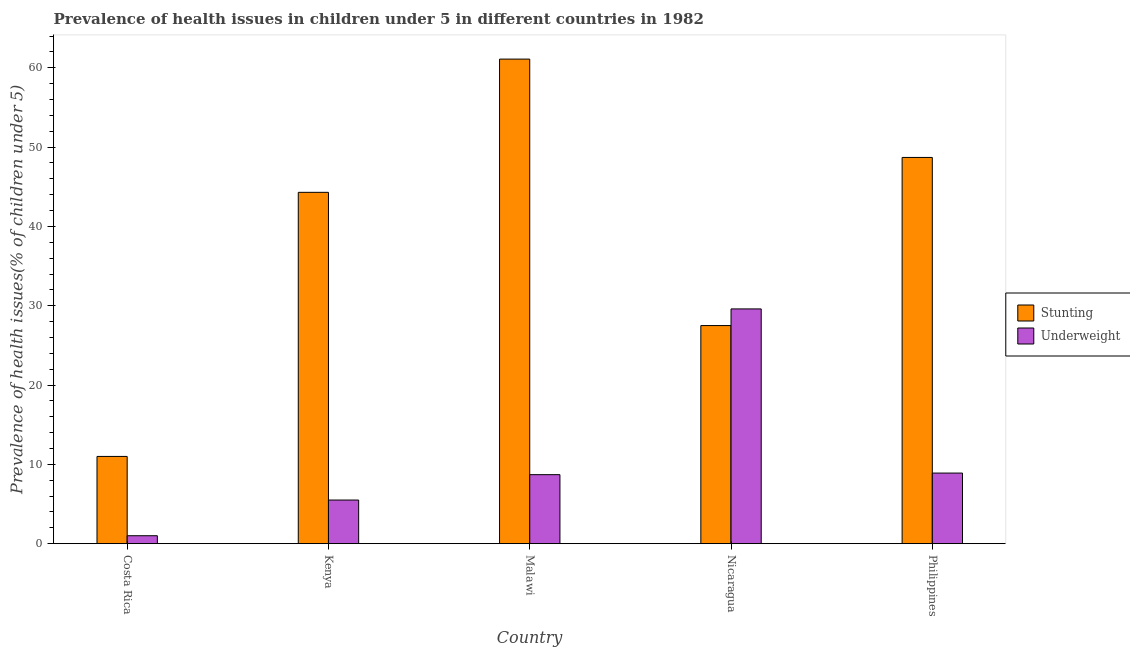Are the number of bars on each tick of the X-axis equal?
Provide a short and direct response. Yes. How many bars are there on the 2nd tick from the left?
Give a very brief answer. 2. What is the label of the 4th group of bars from the left?
Give a very brief answer. Nicaragua. In how many cases, is the number of bars for a given country not equal to the number of legend labels?
Offer a very short reply. 0. What is the percentage of stunted children in Philippines?
Offer a terse response. 48.7. Across all countries, what is the maximum percentage of underweight children?
Your response must be concise. 29.6. In which country was the percentage of stunted children maximum?
Ensure brevity in your answer.  Malawi. In which country was the percentage of underweight children minimum?
Keep it short and to the point. Costa Rica. What is the total percentage of stunted children in the graph?
Keep it short and to the point. 192.6. What is the difference between the percentage of stunted children in Costa Rica and that in Philippines?
Offer a very short reply. -37.7. What is the difference between the percentage of stunted children in Costa Rica and the percentage of underweight children in Nicaragua?
Your answer should be compact. -18.6. What is the average percentage of stunted children per country?
Your answer should be compact. 38.52. What is the difference between the percentage of underweight children and percentage of stunted children in Costa Rica?
Offer a terse response. -10. What is the ratio of the percentage of underweight children in Malawi to that in Philippines?
Provide a short and direct response. 0.98. Is the difference between the percentage of stunted children in Kenya and Philippines greater than the difference between the percentage of underweight children in Kenya and Philippines?
Provide a succinct answer. No. What is the difference between the highest and the second highest percentage of stunted children?
Your answer should be compact. 12.4. What is the difference between the highest and the lowest percentage of stunted children?
Keep it short and to the point. 50.1. In how many countries, is the percentage of stunted children greater than the average percentage of stunted children taken over all countries?
Offer a terse response. 3. What does the 2nd bar from the left in Philippines represents?
Make the answer very short. Underweight. What does the 1st bar from the right in Kenya represents?
Your answer should be very brief. Underweight. Are all the bars in the graph horizontal?
Ensure brevity in your answer.  No. Does the graph contain grids?
Give a very brief answer. No. What is the title of the graph?
Offer a very short reply. Prevalence of health issues in children under 5 in different countries in 1982. Does "Infant" appear as one of the legend labels in the graph?
Keep it short and to the point. No. What is the label or title of the X-axis?
Your response must be concise. Country. What is the label or title of the Y-axis?
Your answer should be very brief. Prevalence of health issues(% of children under 5). What is the Prevalence of health issues(% of children under 5) of Underweight in Costa Rica?
Provide a succinct answer. 1. What is the Prevalence of health issues(% of children under 5) of Stunting in Kenya?
Your answer should be compact. 44.3. What is the Prevalence of health issues(% of children under 5) in Stunting in Malawi?
Offer a very short reply. 61.1. What is the Prevalence of health issues(% of children under 5) in Underweight in Malawi?
Keep it short and to the point. 8.7. What is the Prevalence of health issues(% of children under 5) in Stunting in Nicaragua?
Make the answer very short. 27.5. What is the Prevalence of health issues(% of children under 5) in Underweight in Nicaragua?
Ensure brevity in your answer.  29.6. What is the Prevalence of health issues(% of children under 5) in Stunting in Philippines?
Make the answer very short. 48.7. What is the Prevalence of health issues(% of children under 5) of Underweight in Philippines?
Keep it short and to the point. 8.9. Across all countries, what is the maximum Prevalence of health issues(% of children under 5) of Stunting?
Give a very brief answer. 61.1. Across all countries, what is the maximum Prevalence of health issues(% of children under 5) in Underweight?
Provide a succinct answer. 29.6. Across all countries, what is the minimum Prevalence of health issues(% of children under 5) of Stunting?
Keep it short and to the point. 11. What is the total Prevalence of health issues(% of children under 5) of Stunting in the graph?
Ensure brevity in your answer.  192.6. What is the total Prevalence of health issues(% of children under 5) of Underweight in the graph?
Keep it short and to the point. 53.7. What is the difference between the Prevalence of health issues(% of children under 5) of Stunting in Costa Rica and that in Kenya?
Provide a short and direct response. -33.3. What is the difference between the Prevalence of health issues(% of children under 5) of Stunting in Costa Rica and that in Malawi?
Offer a terse response. -50.1. What is the difference between the Prevalence of health issues(% of children under 5) in Underweight in Costa Rica and that in Malawi?
Offer a very short reply. -7.7. What is the difference between the Prevalence of health issues(% of children under 5) of Stunting in Costa Rica and that in Nicaragua?
Ensure brevity in your answer.  -16.5. What is the difference between the Prevalence of health issues(% of children under 5) in Underweight in Costa Rica and that in Nicaragua?
Keep it short and to the point. -28.6. What is the difference between the Prevalence of health issues(% of children under 5) of Stunting in Costa Rica and that in Philippines?
Provide a succinct answer. -37.7. What is the difference between the Prevalence of health issues(% of children under 5) in Stunting in Kenya and that in Malawi?
Keep it short and to the point. -16.8. What is the difference between the Prevalence of health issues(% of children under 5) of Stunting in Kenya and that in Nicaragua?
Provide a short and direct response. 16.8. What is the difference between the Prevalence of health issues(% of children under 5) in Underweight in Kenya and that in Nicaragua?
Offer a very short reply. -24.1. What is the difference between the Prevalence of health issues(% of children under 5) of Stunting in Kenya and that in Philippines?
Your response must be concise. -4.4. What is the difference between the Prevalence of health issues(% of children under 5) in Stunting in Malawi and that in Nicaragua?
Keep it short and to the point. 33.6. What is the difference between the Prevalence of health issues(% of children under 5) of Underweight in Malawi and that in Nicaragua?
Your response must be concise. -20.9. What is the difference between the Prevalence of health issues(% of children under 5) in Underweight in Malawi and that in Philippines?
Keep it short and to the point. -0.2. What is the difference between the Prevalence of health issues(% of children under 5) of Stunting in Nicaragua and that in Philippines?
Keep it short and to the point. -21.2. What is the difference between the Prevalence of health issues(% of children under 5) of Underweight in Nicaragua and that in Philippines?
Provide a short and direct response. 20.7. What is the difference between the Prevalence of health issues(% of children under 5) in Stunting in Costa Rica and the Prevalence of health issues(% of children under 5) in Underweight in Kenya?
Provide a short and direct response. 5.5. What is the difference between the Prevalence of health issues(% of children under 5) in Stunting in Costa Rica and the Prevalence of health issues(% of children under 5) in Underweight in Nicaragua?
Your answer should be compact. -18.6. What is the difference between the Prevalence of health issues(% of children under 5) in Stunting in Costa Rica and the Prevalence of health issues(% of children under 5) in Underweight in Philippines?
Your answer should be compact. 2.1. What is the difference between the Prevalence of health issues(% of children under 5) in Stunting in Kenya and the Prevalence of health issues(% of children under 5) in Underweight in Malawi?
Provide a short and direct response. 35.6. What is the difference between the Prevalence of health issues(% of children under 5) of Stunting in Kenya and the Prevalence of health issues(% of children under 5) of Underweight in Philippines?
Offer a terse response. 35.4. What is the difference between the Prevalence of health issues(% of children under 5) of Stunting in Malawi and the Prevalence of health issues(% of children under 5) of Underweight in Nicaragua?
Your response must be concise. 31.5. What is the difference between the Prevalence of health issues(% of children under 5) of Stunting in Malawi and the Prevalence of health issues(% of children under 5) of Underweight in Philippines?
Ensure brevity in your answer.  52.2. What is the difference between the Prevalence of health issues(% of children under 5) of Stunting in Nicaragua and the Prevalence of health issues(% of children under 5) of Underweight in Philippines?
Provide a succinct answer. 18.6. What is the average Prevalence of health issues(% of children under 5) in Stunting per country?
Offer a very short reply. 38.52. What is the average Prevalence of health issues(% of children under 5) of Underweight per country?
Your answer should be compact. 10.74. What is the difference between the Prevalence of health issues(% of children under 5) of Stunting and Prevalence of health issues(% of children under 5) of Underweight in Costa Rica?
Your response must be concise. 10. What is the difference between the Prevalence of health issues(% of children under 5) of Stunting and Prevalence of health issues(% of children under 5) of Underweight in Kenya?
Offer a terse response. 38.8. What is the difference between the Prevalence of health issues(% of children under 5) in Stunting and Prevalence of health issues(% of children under 5) in Underweight in Malawi?
Give a very brief answer. 52.4. What is the difference between the Prevalence of health issues(% of children under 5) in Stunting and Prevalence of health issues(% of children under 5) in Underweight in Nicaragua?
Your answer should be very brief. -2.1. What is the difference between the Prevalence of health issues(% of children under 5) in Stunting and Prevalence of health issues(% of children under 5) in Underweight in Philippines?
Provide a succinct answer. 39.8. What is the ratio of the Prevalence of health issues(% of children under 5) of Stunting in Costa Rica to that in Kenya?
Make the answer very short. 0.25. What is the ratio of the Prevalence of health issues(% of children under 5) in Underweight in Costa Rica to that in Kenya?
Give a very brief answer. 0.18. What is the ratio of the Prevalence of health issues(% of children under 5) of Stunting in Costa Rica to that in Malawi?
Your response must be concise. 0.18. What is the ratio of the Prevalence of health issues(% of children under 5) of Underweight in Costa Rica to that in Malawi?
Provide a short and direct response. 0.11. What is the ratio of the Prevalence of health issues(% of children under 5) in Underweight in Costa Rica to that in Nicaragua?
Keep it short and to the point. 0.03. What is the ratio of the Prevalence of health issues(% of children under 5) of Stunting in Costa Rica to that in Philippines?
Offer a terse response. 0.23. What is the ratio of the Prevalence of health issues(% of children under 5) in Underweight in Costa Rica to that in Philippines?
Make the answer very short. 0.11. What is the ratio of the Prevalence of health issues(% of children under 5) in Stunting in Kenya to that in Malawi?
Ensure brevity in your answer.  0.72. What is the ratio of the Prevalence of health issues(% of children under 5) of Underweight in Kenya to that in Malawi?
Provide a succinct answer. 0.63. What is the ratio of the Prevalence of health issues(% of children under 5) in Stunting in Kenya to that in Nicaragua?
Offer a very short reply. 1.61. What is the ratio of the Prevalence of health issues(% of children under 5) of Underweight in Kenya to that in Nicaragua?
Your answer should be compact. 0.19. What is the ratio of the Prevalence of health issues(% of children under 5) in Stunting in Kenya to that in Philippines?
Keep it short and to the point. 0.91. What is the ratio of the Prevalence of health issues(% of children under 5) of Underweight in Kenya to that in Philippines?
Your response must be concise. 0.62. What is the ratio of the Prevalence of health issues(% of children under 5) of Stunting in Malawi to that in Nicaragua?
Provide a succinct answer. 2.22. What is the ratio of the Prevalence of health issues(% of children under 5) in Underweight in Malawi to that in Nicaragua?
Offer a terse response. 0.29. What is the ratio of the Prevalence of health issues(% of children under 5) of Stunting in Malawi to that in Philippines?
Your answer should be compact. 1.25. What is the ratio of the Prevalence of health issues(% of children under 5) of Underweight in Malawi to that in Philippines?
Your answer should be compact. 0.98. What is the ratio of the Prevalence of health issues(% of children under 5) in Stunting in Nicaragua to that in Philippines?
Provide a succinct answer. 0.56. What is the ratio of the Prevalence of health issues(% of children under 5) in Underweight in Nicaragua to that in Philippines?
Make the answer very short. 3.33. What is the difference between the highest and the second highest Prevalence of health issues(% of children under 5) of Underweight?
Offer a very short reply. 20.7. What is the difference between the highest and the lowest Prevalence of health issues(% of children under 5) of Stunting?
Provide a succinct answer. 50.1. What is the difference between the highest and the lowest Prevalence of health issues(% of children under 5) of Underweight?
Your answer should be compact. 28.6. 